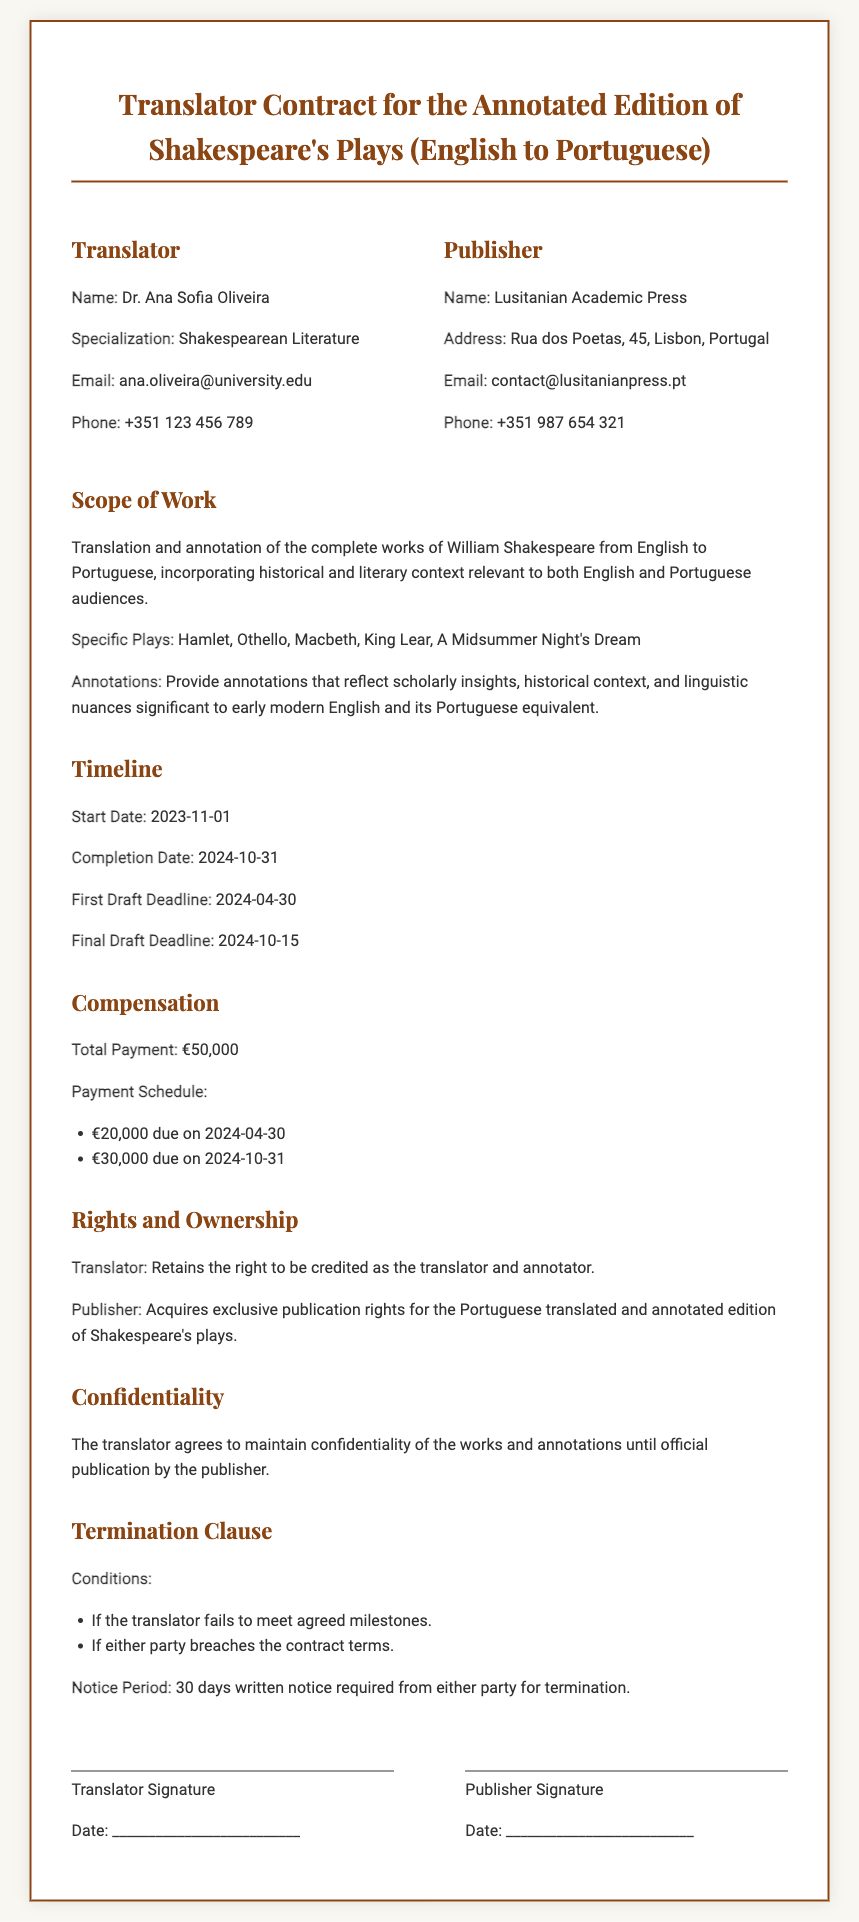What is the name of the translator? The translator's name is provided in the document under the Translator section.
Answer: Dr. Ana Sofia Oliveira What is the total payment for the project? The total payment amount is explicitly stated in the Compensation section.
Answer: €50,000 What is the start date of the contract? The start date is specified in the Timeline section.
Answer: 2023-11-01 What is the final draft deadline? The final draft deadline is listed in the Timeline section.
Answer: 2024-10-15 Which publisher is involved in this contract? The publisher's name is mentioned in the Publisher section of the document.
Answer: Lusitanian Academic Press What plays are included in the translation? The specific plays to be translated are listed in the Scope of Work section.
Answer: Hamlet, Othello, Macbeth, King Lear, A Midsummer Night's Dream How much is due on the first draft deadline? The payment due on the first draft deadline is detailed in the Compensation section.
Answer: €20,000 What is the notice period required for termination? The notice period for termination is stated in the Termination Clause section.
Answer: 30 days What rights does the translator retain? The rights retained by the translator are specified in the Rights and Ownership section.
Answer: Right to be credited as the translator and annotator 